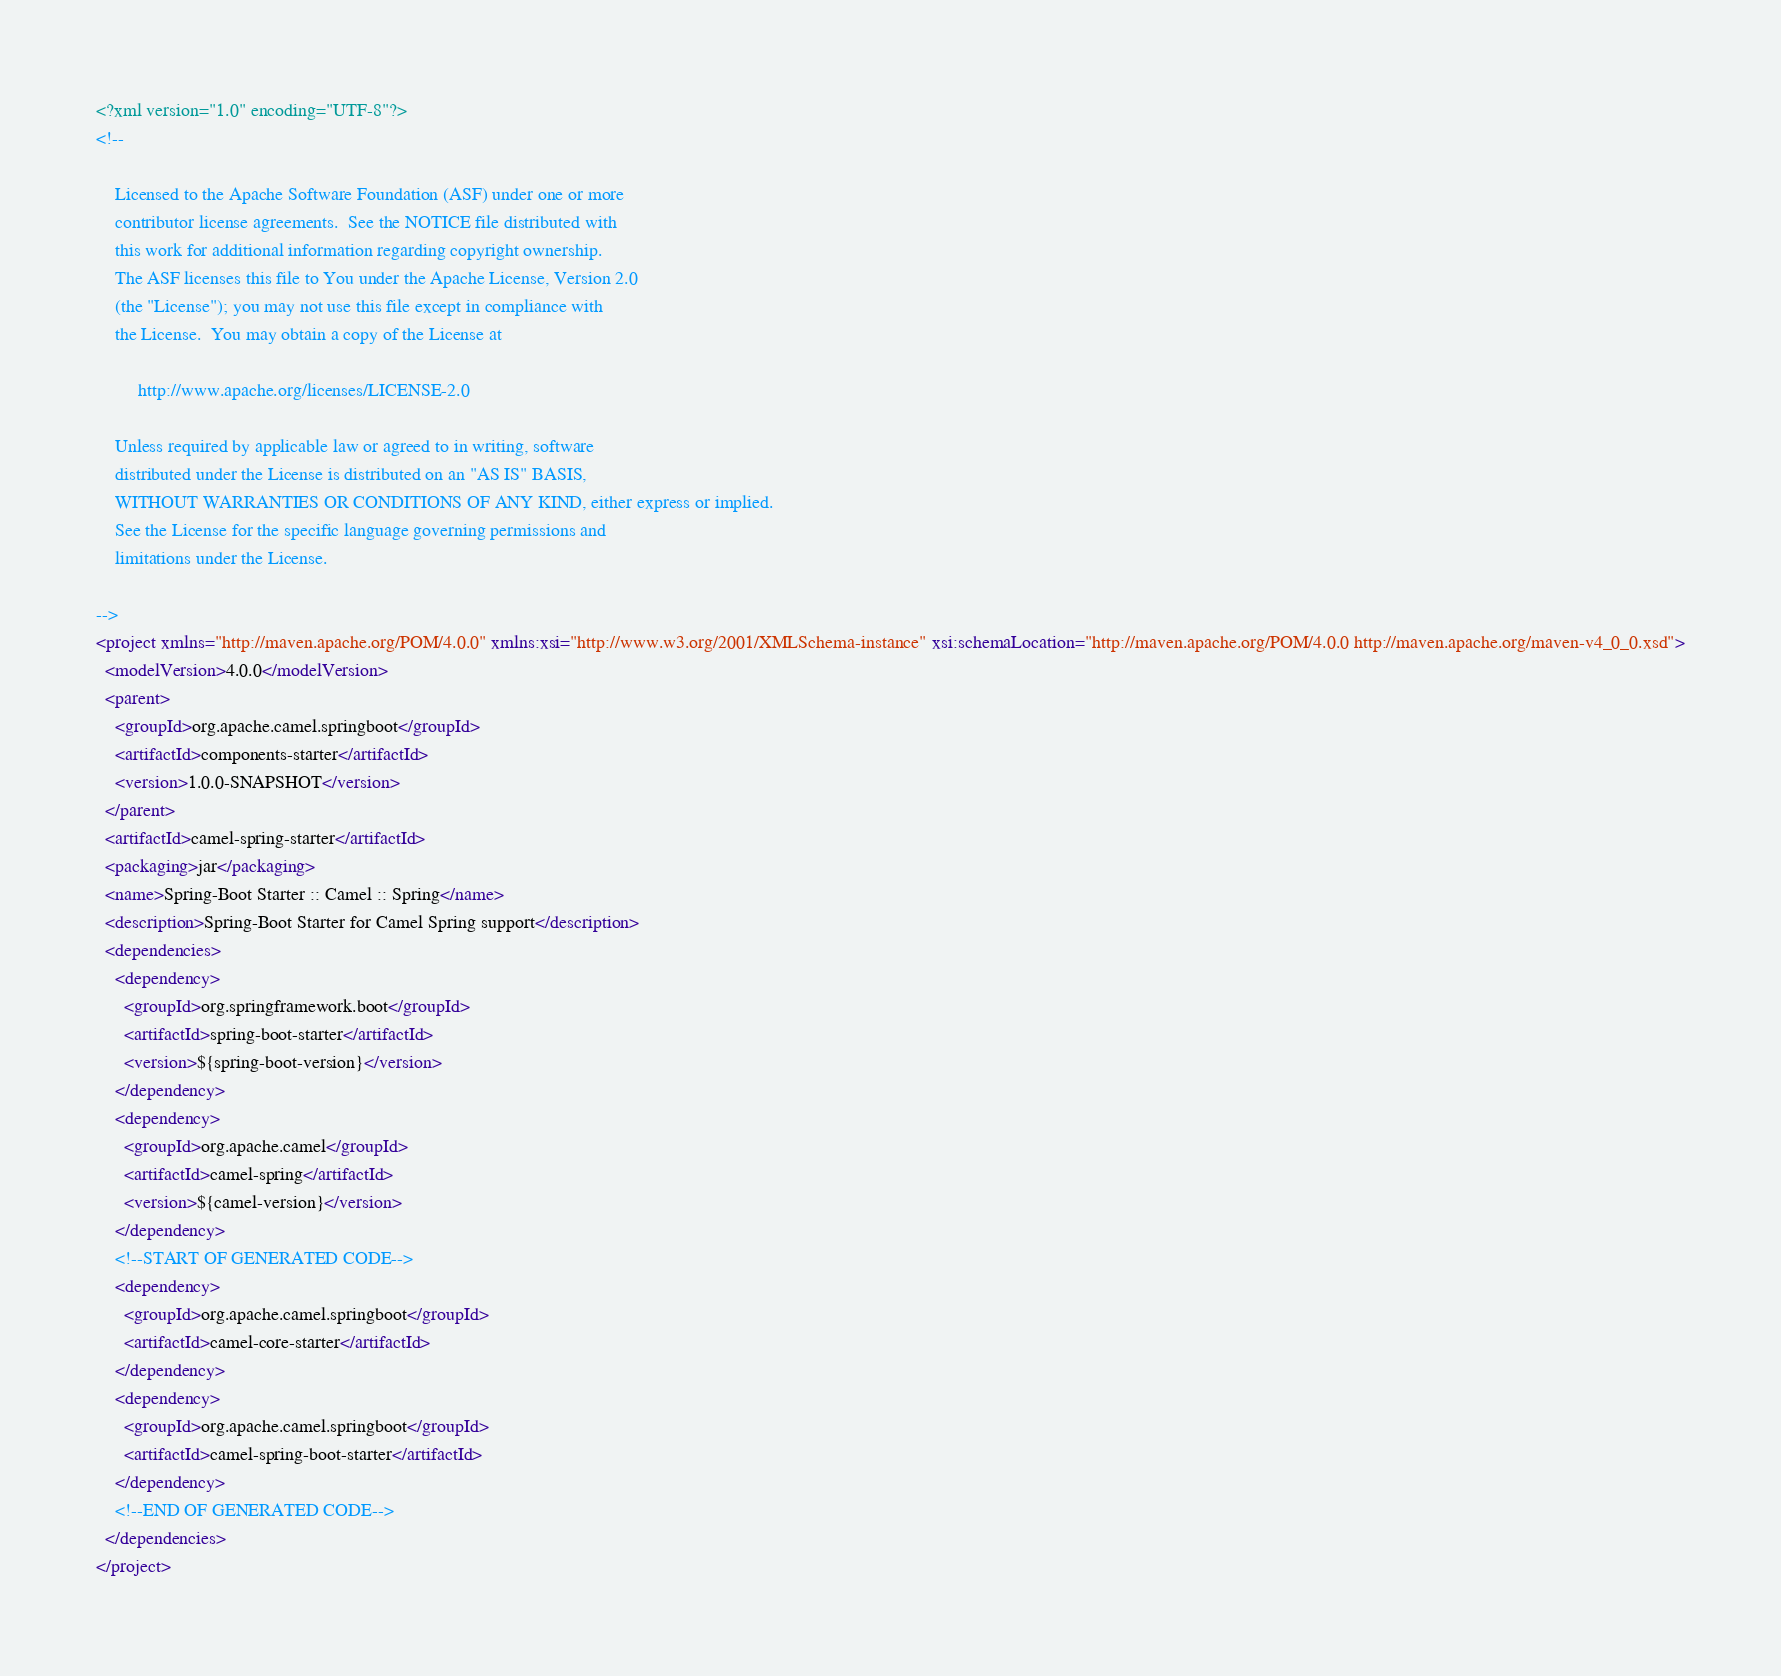Convert code to text. <code><loc_0><loc_0><loc_500><loc_500><_XML_><?xml version="1.0" encoding="UTF-8"?>
<!--

    Licensed to the Apache Software Foundation (ASF) under one or more
    contributor license agreements.  See the NOTICE file distributed with
    this work for additional information regarding copyright ownership.
    The ASF licenses this file to You under the Apache License, Version 2.0
    (the "License"); you may not use this file except in compliance with
    the License.  You may obtain a copy of the License at

         http://www.apache.org/licenses/LICENSE-2.0

    Unless required by applicable law or agreed to in writing, software
    distributed under the License is distributed on an "AS IS" BASIS,
    WITHOUT WARRANTIES OR CONDITIONS OF ANY KIND, either express or implied.
    See the License for the specific language governing permissions and
    limitations under the License.

-->
<project xmlns="http://maven.apache.org/POM/4.0.0" xmlns:xsi="http://www.w3.org/2001/XMLSchema-instance" xsi:schemaLocation="http://maven.apache.org/POM/4.0.0 http://maven.apache.org/maven-v4_0_0.xsd">
  <modelVersion>4.0.0</modelVersion>
  <parent>
    <groupId>org.apache.camel.springboot</groupId>
    <artifactId>components-starter</artifactId>
    <version>1.0.0-SNAPSHOT</version>
  </parent>
  <artifactId>camel-spring-starter</artifactId>
  <packaging>jar</packaging>
  <name>Spring-Boot Starter :: Camel :: Spring</name>
  <description>Spring-Boot Starter for Camel Spring support</description>
  <dependencies>
    <dependency>
      <groupId>org.springframework.boot</groupId>
      <artifactId>spring-boot-starter</artifactId>
      <version>${spring-boot-version}</version>
    </dependency>
    <dependency>
      <groupId>org.apache.camel</groupId>
      <artifactId>camel-spring</artifactId>
      <version>${camel-version}</version>
    </dependency>
    <!--START OF GENERATED CODE-->
    <dependency>
      <groupId>org.apache.camel.springboot</groupId>
      <artifactId>camel-core-starter</artifactId>
    </dependency>
    <dependency>
      <groupId>org.apache.camel.springboot</groupId>
      <artifactId>camel-spring-boot-starter</artifactId>
    </dependency>
    <!--END OF GENERATED CODE-->
  </dependencies>
</project>
</code> 